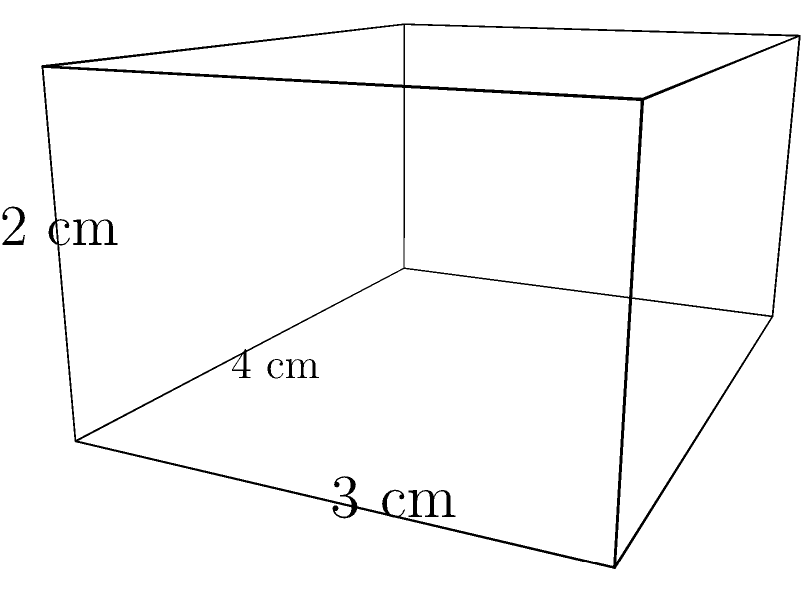As part of a digital learning module on geometry, you need to create an interactive question about calculating surface area. Using the provided 3D model of a rectangular prism, how would you guide students to find its total surface area? To find the surface area of a rectangular prism, we need to calculate the area of each face and sum them up. Let's break it down step-by-step:

1. Identify the dimensions:
   Length (l) = 4 cm
   Width (w) = 3 cm
   Height (h) = 2 cm

2. Calculate the areas of each pair of faces:
   a. Front and back faces: $A_1 = 2(l \times h) = 2(4 \times 2) = 16$ cm²
   b. Top and bottom faces: $A_2 = 2(l \times w) = 2(4 \times 3) = 24$ cm²
   c. Left and right faces: $A_3 = 2(w \times h) = 2(3 \times 2) = 12$ cm²

3. Sum up all the areas:
   Total Surface Area = $A_1 + A_2 + A_3 = 16 + 24 + 12 = 52$ cm²

Therefore, the total surface area of the rectangular prism is 52 square centimeters.
Answer: 52 cm² 